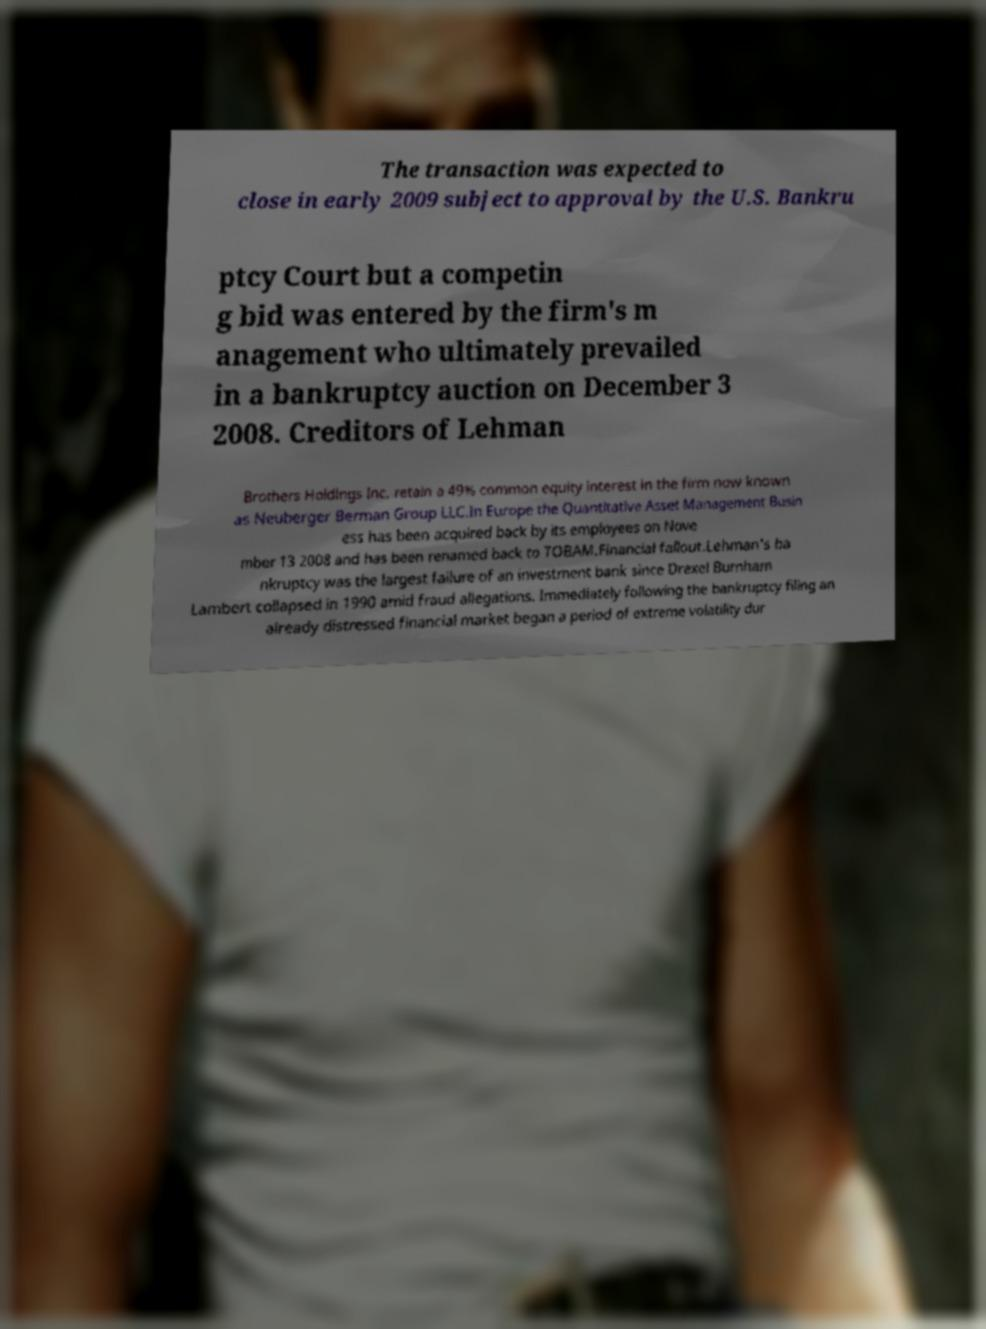Could you extract and type out the text from this image? The transaction was expected to close in early 2009 subject to approval by the U.S. Bankru ptcy Court but a competin g bid was entered by the firm's m anagement who ultimately prevailed in a bankruptcy auction on December 3 2008. Creditors of Lehman Brothers Holdings Inc. retain a 49% common equity interest in the firm now known as Neuberger Berman Group LLC.In Europe the Quantitative Asset Management Busin ess has been acquired back by its employees on Nove mber 13 2008 and has been renamed back to TOBAM.Financial fallout.Lehman's ba nkruptcy was the largest failure of an investment bank since Drexel Burnham Lambert collapsed in 1990 amid fraud allegations. Immediately following the bankruptcy filing an already distressed financial market began a period of extreme volatility dur 